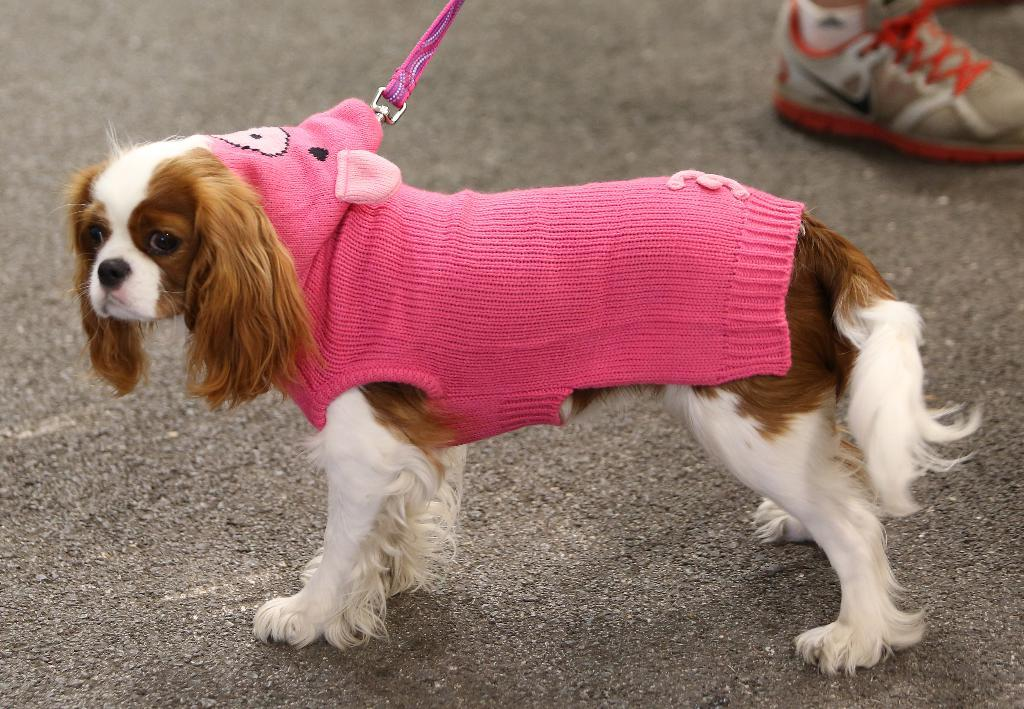What type of animal is in the image? There is a dog in the image. What is the dog wearing? The dog is wearing pink clothes. Can you describe any accessories the dog has? The dog has a belt. What can be seen in the background of the image? There are shoes and a road visible in the background of the image. What type of trousers is the dog wearing in the image? The dog is not wearing trousers in the image; it is wearing pink clothes. Can you tell me which team the dog is playing for in the image? There is no indication of a team or any sports activity in the image. 